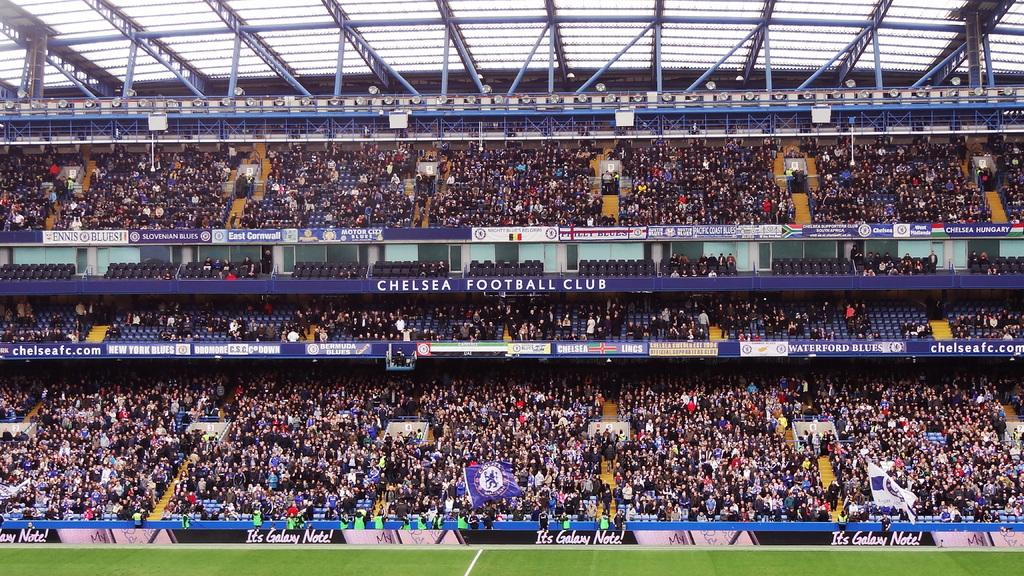<image>
Describe the image concisely. Many people are in the stands at the Chelsea Football Club stadium. 